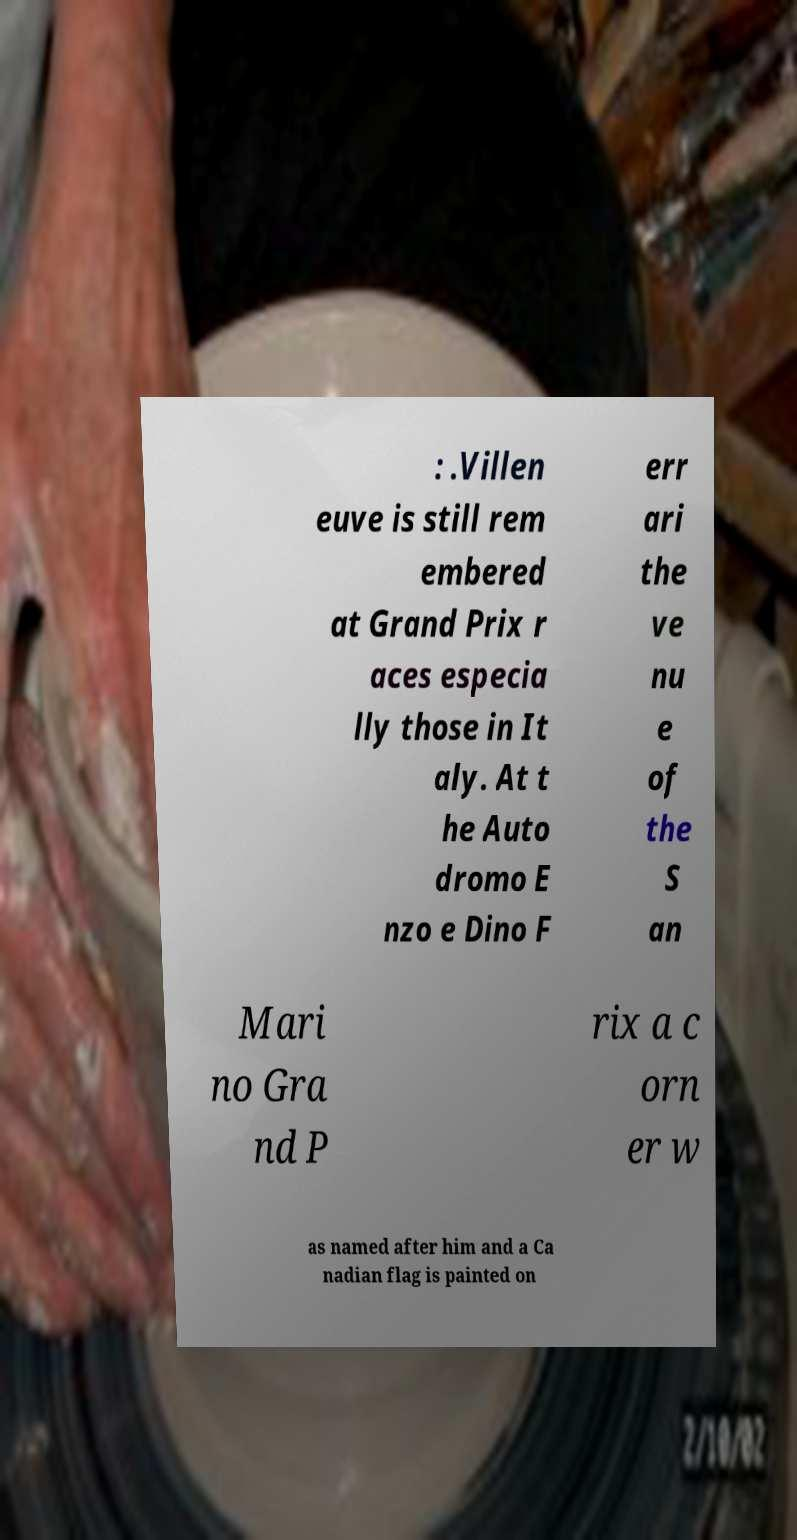Can you accurately transcribe the text from the provided image for me? : .Villen euve is still rem embered at Grand Prix r aces especia lly those in It aly. At t he Auto dromo E nzo e Dino F err ari the ve nu e of the S an Mari no Gra nd P rix a c orn er w as named after him and a Ca nadian flag is painted on 